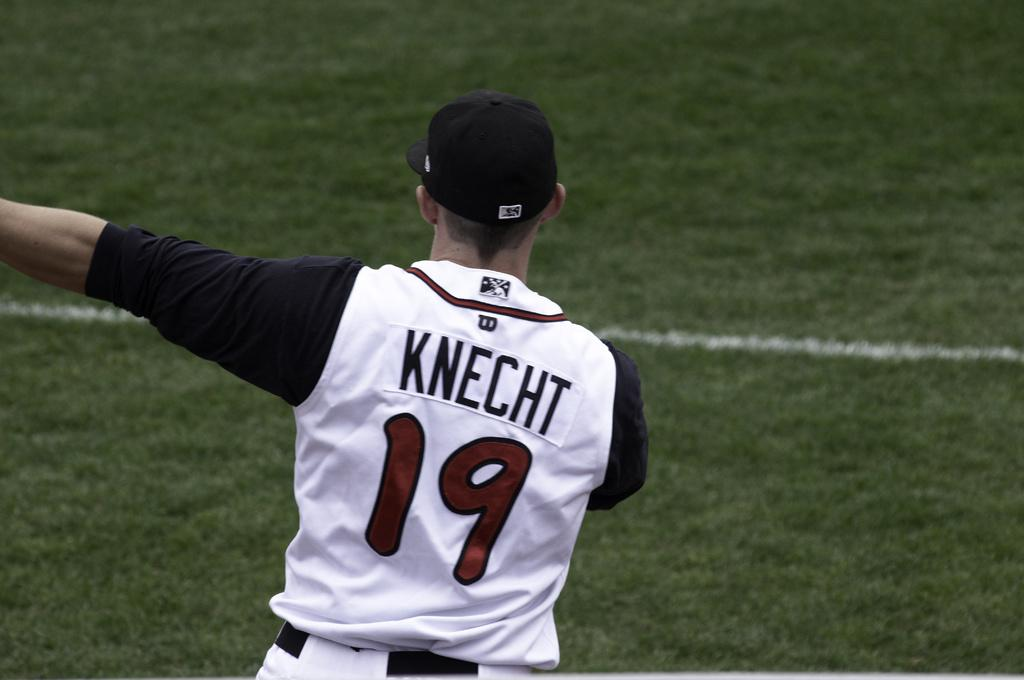<image>
Provide a brief description of the given image. A baseball player is pointing on the field and his uniform says Knecht 19. 